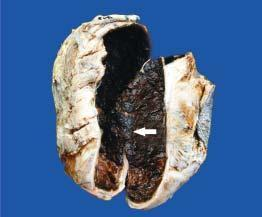what does sectioned surface of the sac show?
Answer the question using a single word or phrase. Thick wall coated internally by brownish 